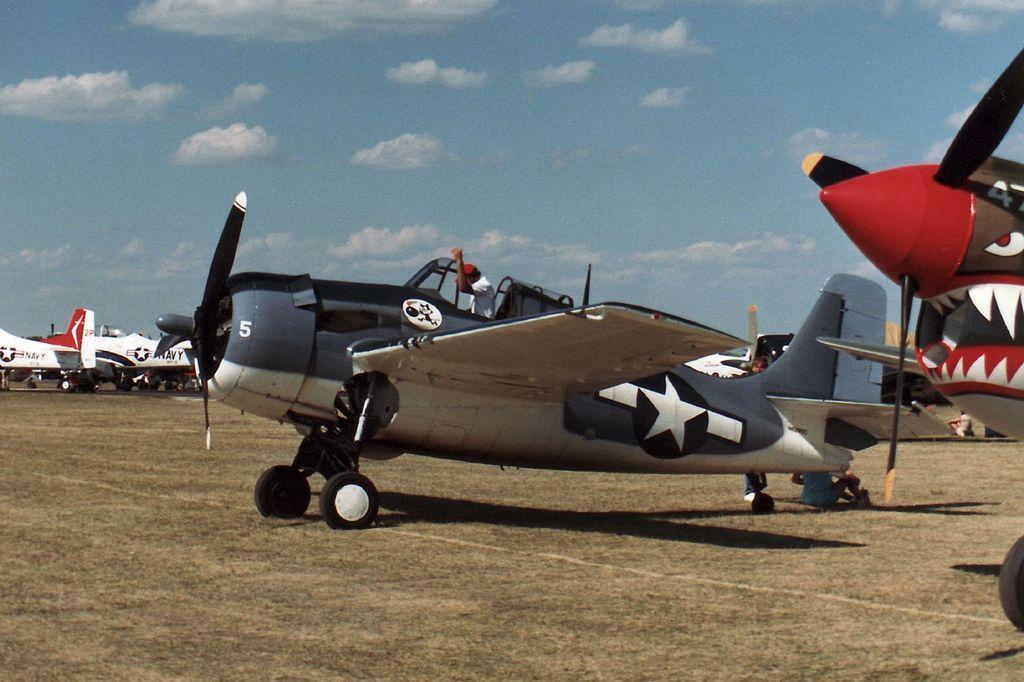Describe this image in one or two sentences. In this images we can see planes on the ground and a person is sitting on the planes. In the background there are few persons and clouds in the sky. 